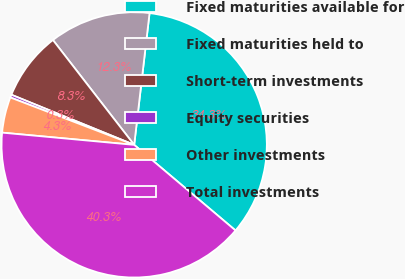Convert chart. <chart><loc_0><loc_0><loc_500><loc_500><pie_chart><fcel>Fixed maturities available for<fcel>Fixed maturities held to<fcel>Short-term investments<fcel>Equity securities<fcel>Other investments<fcel>Total investments<nl><fcel>34.32%<fcel>12.34%<fcel>8.34%<fcel>0.35%<fcel>4.35%<fcel>40.31%<nl></chart> 